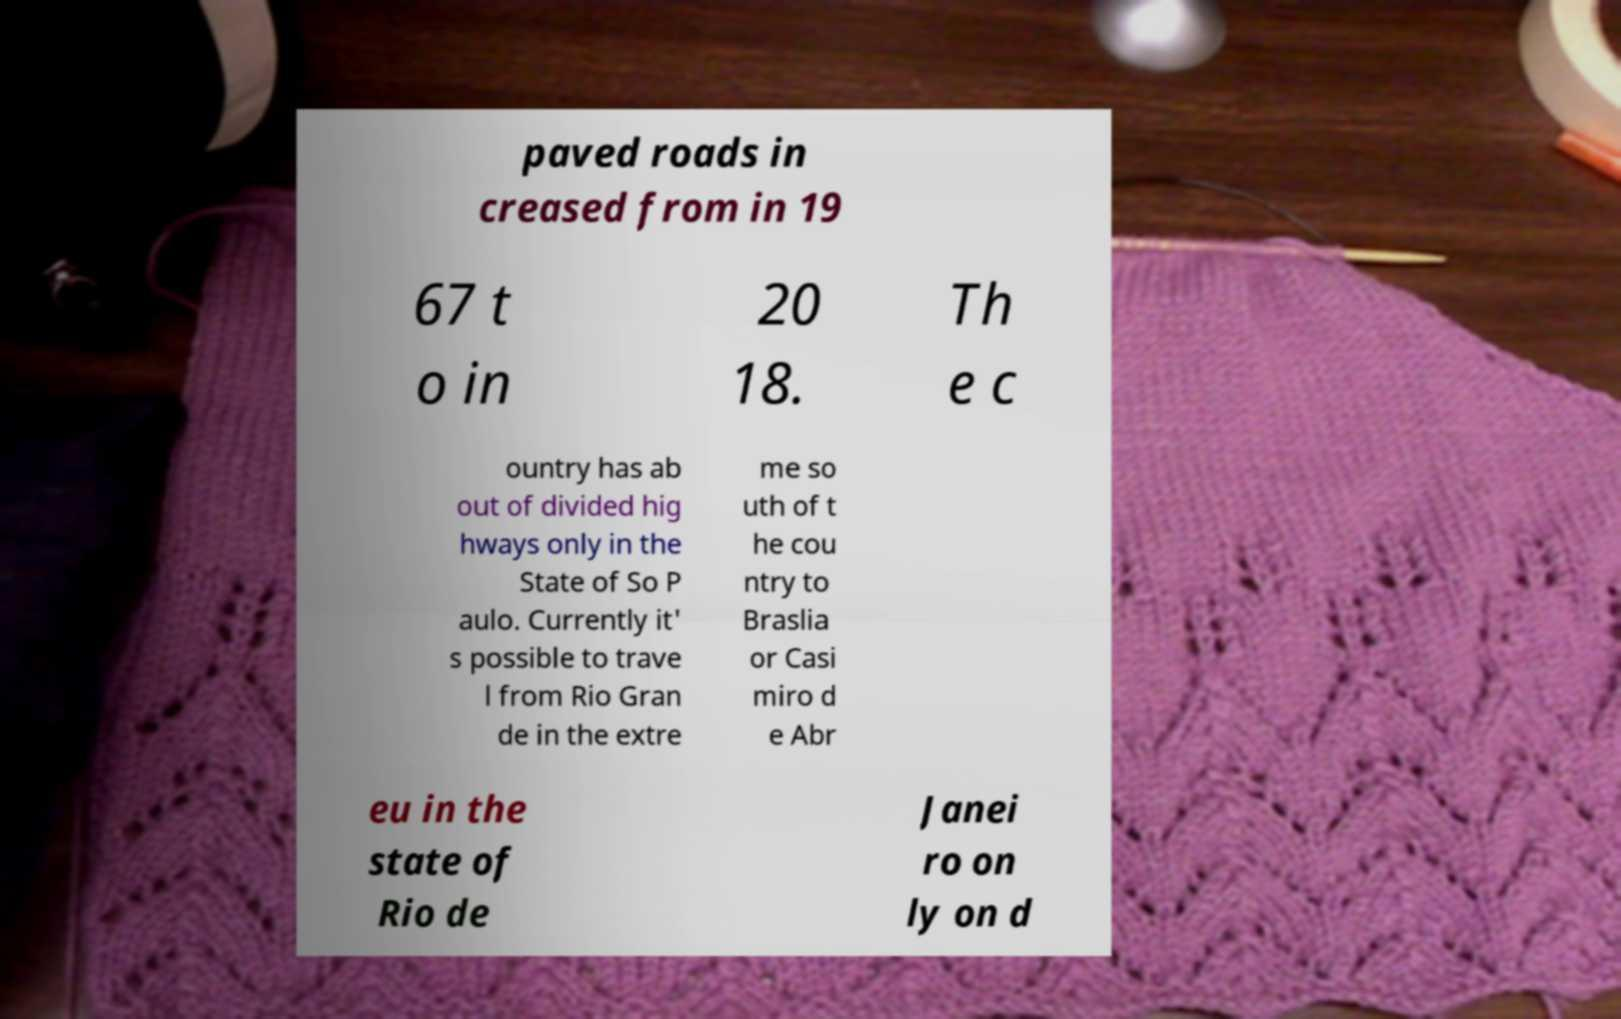I need the written content from this picture converted into text. Can you do that? paved roads in creased from in 19 67 t o in 20 18. Th e c ountry has ab out of divided hig hways only in the State of So P aulo. Currently it' s possible to trave l from Rio Gran de in the extre me so uth of t he cou ntry to Braslia or Casi miro d e Abr eu in the state of Rio de Janei ro on ly on d 